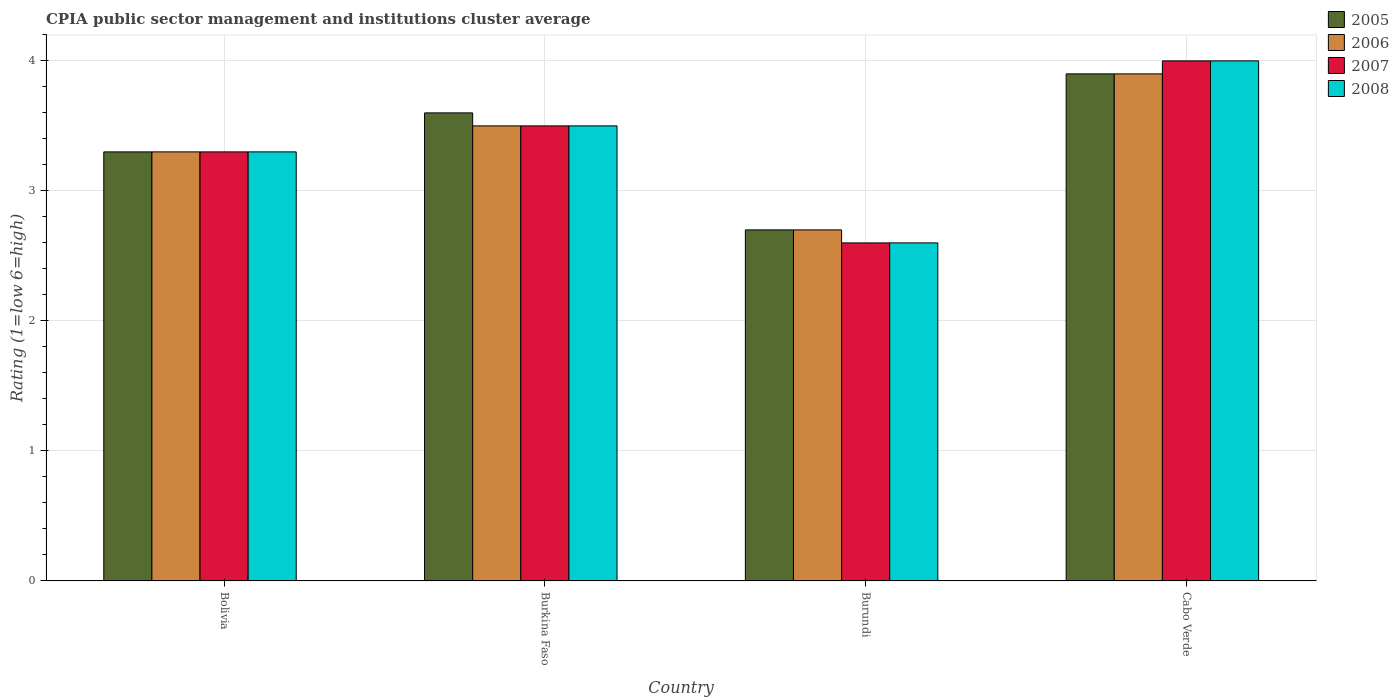How many different coloured bars are there?
Keep it short and to the point. 4. Are the number of bars per tick equal to the number of legend labels?
Ensure brevity in your answer.  Yes. Are the number of bars on each tick of the X-axis equal?
Provide a short and direct response. Yes. How many bars are there on the 4th tick from the right?
Offer a terse response. 4. What is the label of the 4th group of bars from the left?
Provide a succinct answer. Cabo Verde. In how many cases, is the number of bars for a given country not equal to the number of legend labels?
Keep it short and to the point. 0. In which country was the CPIA rating in 2008 maximum?
Make the answer very short. Cabo Verde. In which country was the CPIA rating in 2006 minimum?
Your answer should be compact. Burundi. What is the total CPIA rating in 2008 in the graph?
Your response must be concise. 13.4. What is the difference between the CPIA rating in 2008 in Burkina Faso and that in Burundi?
Keep it short and to the point. 0.9. What is the difference between the CPIA rating in 2007 in Bolivia and the CPIA rating in 2006 in Burundi?
Provide a short and direct response. 0.6. What is the average CPIA rating in 2008 per country?
Give a very brief answer. 3.35. What is the difference between the CPIA rating of/in 2005 and CPIA rating of/in 2007 in Bolivia?
Offer a terse response. 0. In how many countries, is the CPIA rating in 2007 greater than 3.2?
Keep it short and to the point. 3. What is the ratio of the CPIA rating in 2008 in Bolivia to that in Burkina Faso?
Your response must be concise. 0.94. What is the difference between the highest and the second highest CPIA rating in 2005?
Ensure brevity in your answer.  -0.3. In how many countries, is the CPIA rating in 2006 greater than the average CPIA rating in 2006 taken over all countries?
Ensure brevity in your answer.  2. Is the sum of the CPIA rating in 2005 in Burkina Faso and Cabo Verde greater than the maximum CPIA rating in 2006 across all countries?
Your answer should be compact. Yes. What does the 3rd bar from the right in Burkina Faso represents?
Ensure brevity in your answer.  2006. Are all the bars in the graph horizontal?
Ensure brevity in your answer.  No. Are the values on the major ticks of Y-axis written in scientific E-notation?
Your response must be concise. No. How are the legend labels stacked?
Ensure brevity in your answer.  Vertical. What is the title of the graph?
Provide a succinct answer. CPIA public sector management and institutions cluster average. Does "1981" appear as one of the legend labels in the graph?
Give a very brief answer. No. What is the label or title of the Y-axis?
Provide a short and direct response. Rating (1=low 6=high). What is the Rating (1=low 6=high) of 2006 in Bolivia?
Your answer should be compact. 3.3. What is the Rating (1=low 6=high) in 2007 in Bolivia?
Your answer should be compact. 3.3. What is the Rating (1=low 6=high) in 2008 in Bolivia?
Offer a very short reply. 3.3. What is the Rating (1=low 6=high) in 2005 in Burkina Faso?
Your answer should be very brief. 3.6. What is the Rating (1=low 6=high) of 2008 in Burkina Faso?
Offer a very short reply. 3.5. What is the Rating (1=low 6=high) of 2005 in Burundi?
Provide a succinct answer. 2.7. What is the Rating (1=low 6=high) in 2007 in Burundi?
Keep it short and to the point. 2.6. What is the Rating (1=low 6=high) in 2008 in Burundi?
Your response must be concise. 2.6. What is the Rating (1=low 6=high) of 2005 in Cabo Verde?
Provide a short and direct response. 3.9. What is the Rating (1=low 6=high) in 2007 in Cabo Verde?
Offer a terse response. 4. Across all countries, what is the maximum Rating (1=low 6=high) in 2005?
Your response must be concise. 3.9. Across all countries, what is the maximum Rating (1=low 6=high) in 2007?
Provide a succinct answer. 4. Across all countries, what is the minimum Rating (1=low 6=high) of 2006?
Provide a short and direct response. 2.7. Across all countries, what is the minimum Rating (1=low 6=high) of 2007?
Provide a succinct answer. 2.6. Across all countries, what is the minimum Rating (1=low 6=high) of 2008?
Provide a short and direct response. 2.6. What is the total Rating (1=low 6=high) in 2007 in the graph?
Provide a succinct answer. 13.4. What is the difference between the Rating (1=low 6=high) in 2007 in Bolivia and that in Burkina Faso?
Give a very brief answer. -0.2. What is the difference between the Rating (1=low 6=high) of 2008 in Bolivia and that in Burkina Faso?
Provide a succinct answer. -0.2. What is the difference between the Rating (1=low 6=high) of 2005 in Bolivia and that in Burundi?
Ensure brevity in your answer.  0.6. What is the difference between the Rating (1=low 6=high) of 2006 in Bolivia and that in Burundi?
Provide a succinct answer. 0.6. What is the difference between the Rating (1=low 6=high) of 2007 in Bolivia and that in Burundi?
Provide a succinct answer. 0.7. What is the difference between the Rating (1=low 6=high) in 2008 in Bolivia and that in Burundi?
Provide a short and direct response. 0.7. What is the difference between the Rating (1=low 6=high) in 2005 in Bolivia and that in Cabo Verde?
Provide a short and direct response. -0.6. What is the difference between the Rating (1=low 6=high) of 2008 in Bolivia and that in Cabo Verde?
Provide a short and direct response. -0.7. What is the difference between the Rating (1=low 6=high) of 2006 in Burkina Faso and that in Burundi?
Ensure brevity in your answer.  0.8. What is the difference between the Rating (1=low 6=high) of 2007 in Burkina Faso and that in Burundi?
Offer a very short reply. 0.9. What is the difference between the Rating (1=low 6=high) in 2005 in Burkina Faso and that in Cabo Verde?
Provide a short and direct response. -0.3. What is the difference between the Rating (1=low 6=high) of 2006 in Burkina Faso and that in Cabo Verde?
Make the answer very short. -0.4. What is the difference between the Rating (1=low 6=high) of 2005 in Burundi and that in Cabo Verde?
Offer a very short reply. -1.2. What is the difference between the Rating (1=low 6=high) in 2007 in Burundi and that in Cabo Verde?
Your answer should be very brief. -1.4. What is the difference between the Rating (1=low 6=high) in 2008 in Burundi and that in Cabo Verde?
Offer a very short reply. -1.4. What is the difference between the Rating (1=low 6=high) in 2006 in Bolivia and the Rating (1=low 6=high) in 2007 in Burkina Faso?
Your answer should be very brief. -0.2. What is the difference between the Rating (1=low 6=high) in 2006 in Bolivia and the Rating (1=low 6=high) in 2008 in Burkina Faso?
Your answer should be compact. -0.2. What is the difference between the Rating (1=low 6=high) of 2007 in Bolivia and the Rating (1=low 6=high) of 2008 in Burkina Faso?
Offer a very short reply. -0.2. What is the difference between the Rating (1=low 6=high) in 2005 in Bolivia and the Rating (1=low 6=high) in 2006 in Burundi?
Provide a short and direct response. 0.6. What is the difference between the Rating (1=low 6=high) of 2005 in Bolivia and the Rating (1=low 6=high) of 2008 in Burundi?
Offer a very short reply. 0.7. What is the difference between the Rating (1=low 6=high) in 2007 in Bolivia and the Rating (1=low 6=high) in 2008 in Burundi?
Give a very brief answer. 0.7. What is the difference between the Rating (1=low 6=high) of 2006 in Bolivia and the Rating (1=low 6=high) of 2007 in Cabo Verde?
Ensure brevity in your answer.  -0.7. What is the difference between the Rating (1=low 6=high) in 2007 in Bolivia and the Rating (1=low 6=high) in 2008 in Cabo Verde?
Offer a very short reply. -0.7. What is the difference between the Rating (1=low 6=high) in 2005 in Burkina Faso and the Rating (1=low 6=high) in 2006 in Burundi?
Offer a very short reply. 0.9. What is the difference between the Rating (1=low 6=high) in 2005 in Burkina Faso and the Rating (1=low 6=high) in 2007 in Burundi?
Offer a very short reply. 1. What is the difference between the Rating (1=low 6=high) of 2005 in Burkina Faso and the Rating (1=low 6=high) of 2008 in Burundi?
Your response must be concise. 1. What is the difference between the Rating (1=low 6=high) in 2006 in Burkina Faso and the Rating (1=low 6=high) in 2008 in Burundi?
Your answer should be very brief. 0.9. What is the difference between the Rating (1=low 6=high) in 2007 in Burkina Faso and the Rating (1=low 6=high) in 2008 in Burundi?
Provide a short and direct response. 0.9. What is the difference between the Rating (1=low 6=high) in 2005 in Burkina Faso and the Rating (1=low 6=high) in 2006 in Cabo Verde?
Make the answer very short. -0.3. What is the difference between the Rating (1=low 6=high) in 2005 in Burkina Faso and the Rating (1=low 6=high) in 2008 in Cabo Verde?
Make the answer very short. -0.4. What is the difference between the Rating (1=low 6=high) in 2006 in Burkina Faso and the Rating (1=low 6=high) in 2007 in Cabo Verde?
Your answer should be very brief. -0.5. What is the difference between the Rating (1=low 6=high) of 2006 in Burkina Faso and the Rating (1=low 6=high) of 2008 in Cabo Verde?
Ensure brevity in your answer.  -0.5. What is the difference between the Rating (1=low 6=high) of 2005 in Burundi and the Rating (1=low 6=high) of 2007 in Cabo Verde?
Offer a very short reply. -1.3. What is the difference between the Rating (1=low 6=high) in 2006 in Burundi and the Rating (1=low 6=high) in 2008 in Cabo Verde?
Offer a very short reply. -1.3. What is the average Rating (1=low 6=high) in 2005 per country?
Offer a terse response. 3.38. What is the average Rating (1=low 6=high) of 2006 per country?
Provide a succinct answer. 3.35. What is the average Rating (1=low 6=high) in 2007 per country?
Your response must be concise. 3.35. What is the average Rating (1=low 6=high) of 2008 per country?
Provide a short and direct response. 3.35. What is the difference between the Rating (1=low 6=high) of 2005 and Rating (1=low 6=high) of 2006 in Bolivia?
Offer a very short reply. 0. What is the difference between the Rating (1=low 6=high) of 2005 and Rating (1=low 6=high) of 2007 in Bolivia?
Provide a short and direct response. 0. What is the difference between the Rating (1=low 6=high) of 2005 and Rating (1=low 6=high) of 2008 in Bolivia?
Your answer should be very brief. 0. What is the difference between the Rating (1=low 6=high) in 2006 and Rating (1=low 6=high) in 2007 in Bolivia?
Offer a terse response. 0. What is the difference between the Rating (1=low 6=high) of 2005 and Rating (1=low 6=high) of 2006 in Burkina Faso?
Offer a terse response. 0.1. What is the difference between the Rating (1=low 6=high) in 2005 and Rating (1=low 6=high) in 2007 in Burkina Faso?
Offer a very short reply. 0.1. What is the difference between the Rating (1=low 6=high) in 2005 and Rating (1=low 6=high) in 2008 in Burkina Faso?
Make the answer very short. 0.1. What is the difference between the Rating (1=low 6=high) in 2006 and Rating (1=low 6=high) in 2007 in Burkina Faso?
Your answer should be very brief. 0. What is the difference between the Rating (1=low 6=high) of 2005 and Rating (1=low 6=high) of 2006 in Burundi?
Your answer should be very brief. 0. What is the difference between the Rating (1=low 6=high) of 2005 and Rating (1=low 6=high) of 2007 in Burundi?
Your response must be concise. 0.1. What is the difference between the Rating (1=low 6=high) in 2005 and Rating (1=low 6=high) in 2008 in Burundi?
Make the answer very short. 0.1. What is the difference between the Rating (1=low 6=high) of 2007 and Rating (1=low 6=high) of 2008 in Burundi?
Your response must be concise. 0. What is the difference between the Rating (1=low 6=high) of 2005 and Rating (1=low 6=high) of 2006 in Cabo Verde?
Your answer should be very brief. 0. What is the difference between the Rating (1=low 6=high) of 2005 and Rating (1=low 6=high) of 2007 in Cabo Verde?
Your answer should be compact. -0.1. What is the difference between the Rating (1=low 6=high) of 2006 and Rating (1=low 6=high) of 2008 in Cabo Verde?
Offer a terse response. -0.1. What is the difference between the Rating (1=low 6=high) in 2007 and Rating (1=low 6=high) in 2008 in Cabo Verde?
Your response must be concise. 0. What is the ratio of the Rating (1=low 6=high) of 2006 in Bolivia to that in Burkina Faso?
Offer a very short reply. 0.94. What is the ratio of the Rating (1=low 6=high) in 2007 in Bolivia to that in Burkina Faso?
Make the answer very short. 0.94. What is the ratio of the Rating (1=low 6=high) of 2008 in Bolivia to that in Burkina Faso?
Give a very brief answer. 0.94. What is the ratio of the Rating (1=low 6=high) of 2005 in Bolivia to that in Burundi?
Ensure brevity in your answer.  1.22. What is the ratio of the Rating (1=low 6=high) in 2006 in Bolivia to that in Burundi?
Offer a terse response. 1.22. What is the ratio of the Rating (1=low 6=high) of 2007 in Bolivia to that in Burundi?
Give a very brief answer. 1.27. What is the ratio of the Rating (1=low 6=high) in 2008 in Bolivia to that in Burundi?
Offer a very short reply. 1.27. What is the ratio of the Rating (1=low 6=high) in 2005 in Bolivia to that in Cabo Verde?
Offer a terse response. 0.85. What is the ratio of the Rating (1=low 6=high) of 2006 in Bolivia to that in Cabo Verde?
Your response must be concise. 0.85. What is the ratio of the Rating (1=low 6=high) of 2007 in Bolivia to that in Cabo Verde?
Your answer should be very brief. 0.82. What is the ratio of the Rating (1=low 6=high) in 2008 in Bolivia to that in Cabo Verde?
Ensure brevity in your answer.  0.82. What is the ratio of the Rating (1=low 6=high) of 2006 in Burkina Faso to that in Burundi?
Provide a short and direct response. 1.3. What is the ratio of the Rating (1=low 6=high) in 2007 in Burkina Faso to that in Burundi?
Provide a succinct answer. 1.35. What is the ratio of the Rating (1=low 6=high) in 2008 in Burkina Faso to that in Burundi?
Your response must be concise. 1.35. What is the ratio of the Rating (1=low 6=high) of 2005 in Burkina Faso to that in Cabo Verde?
Your answer should be compact. 0.92. What is the ratio of the Rating (1=low 6=high) in 2006 in Burkina Faso to that in Cabo Verde?
Your answer should be compact. 0.9. What is the ratio of the Rating (1=low 6=high) of 2007 in Burkina Faso to that in Cabo Verde?
Provide a short and direct response. 0.88. What is the ratio of the Rating (1=low 6=high) in 2008 in Burkina Faso to that in Cabo Verde?
Make the answer very short. 0.88. What is the ratio of the Rating (1=low 6=high) of 2005 in Burundi to that in Cabo Verde?
Offer a very short reply. 0.69. What is the ratio of the Rating (1=low 6=high) of 2006 in Burundi to that in Cabo Verde?
Offer a terse response. 0.69. What is the ratio of the Rating (1=low 6=high) of 2007 in Burundi to that in Cabo Verde?
Your answer should be compact. 0.65. What is the ratio of the Rating (1=low 6=high) in 2008 in Burundi to that in Cabo Verde?
Your answer should be compact. 0.65. What is the difference between the highest and the second highest Rating (1=low 6=high) of 2005?
Provide a succinct answer. 0.3. What is the difference between the highest and the second highest Rating (1=low 6=high) in 2006?
Make the answer very short. 0.4. What is the difference between the highest and the second highest Rating (1=low 6=high) of 2007?
Provide a short and direct response. 0.5. What is the difference between the highest and the second highest Rating (1=low 6=high) in 2008?
Your response must be concise. 0.5. What is the difference between the highest and the lowest Rating (1=low 6=high) of 2005?
Ensure brevity in your answer.  1.2. What is the difference between the highest and the lowest Rating (1=low 6=high) of 2006?
Give a very brief answer. 1.2. What is the difference between the highest and the lowest Rating (1=low 6=high) of 2007?
Make the answer very short. 1.4. 